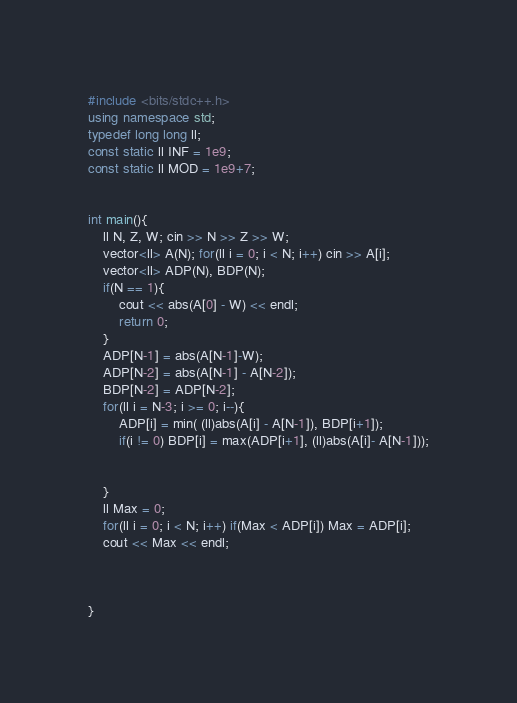Convert code to text. <code><loc_0><loc_0><loc_500><loc_500><_C++_>#include <bits/stdc++.h>
using namespace std;
typedef long long ll;
const static ll INF = 1e9;
const static ll MOD = 1e9+7;


int main(){
    ll N, Z, W; cin >> N >> Z >> W;
    vector<ll> A(N); for(ll i = 0; i < N; i++) cin >> A[i];
    vector<ll> ADP(N), BDP(N);
    if(N == 1){
        cout << abs(A[0] - W) << endl;
        return 0;
    }
    ADP[N-1] = abs(A[N-1]-W);
    ADP[N-2] = abs(A[N-1] - A[N-2]);
    BDP[N-2] = ADP[N-2]; 
    for(ll i = N-3; i >= 0; i--){
        ADP[i] = min( (ll)abs(A[i] - A[N-1]), BDP[i+1]);
        if(i != 0) BDP[i] = max(ADP[i+1], (ll)abs(A[i]- A[N-1]));


    }
    ll Max = 0;
    for(ll i = 0; i < N; i++) if(Max < ADP[i]) Max = ADP[i];
    cout << Max << endl;



}</code> 